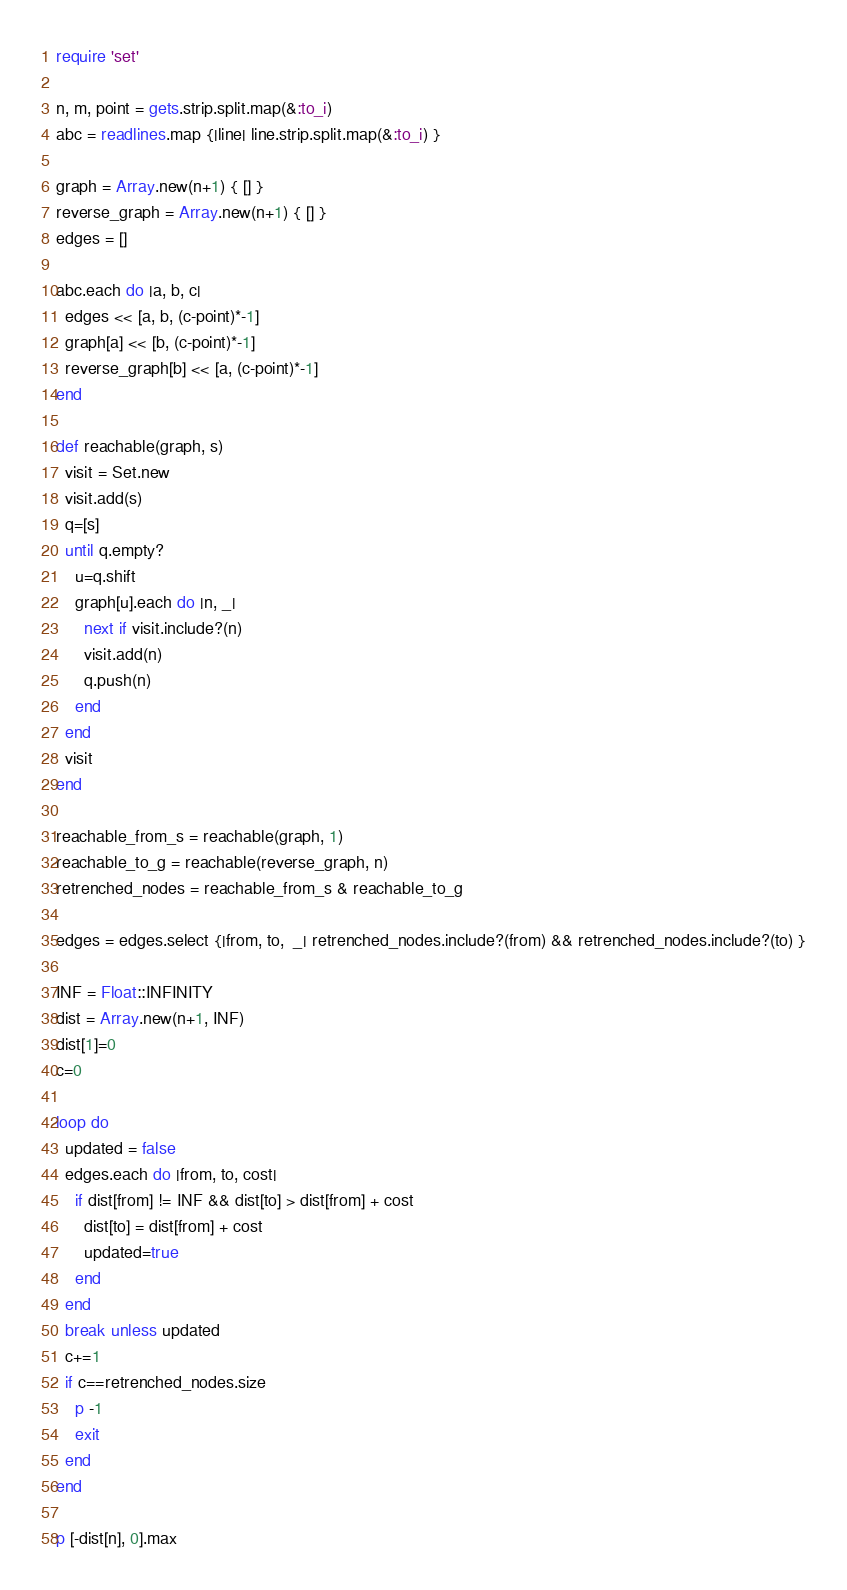Convert code to text. <code><loc_0><loc_0><loc_500><loc_500><_Ruby_>require 'set'

n, m, point = gets.strip.split.map(&:to_i)
abc = readlines.map {|line| line.strip.split.map(&:to_i) }

graph = Array.new(n+1) { [] }
reverse_graph = Array.new(n+1) { [] }
edges = []

abc.each do |a, b, c|
  edges << [a, b, (c-point)*-1]
  graph[a] << [b, (c-point)*-1]
  reverse_graph[b] << [a, (c-point)*-1]
end

def reachable(graph, s)
  visit = Set.new
  visit.add(s)
  q=[s]
  until q.empty?
    u=q.shift
    graph[u].each do |n, _|
      next if visit.include?(n)
      visit.add(n)
      q.push(n)
    end
  end
  visit
end

reachable_from_s = reachable(graph, 1)
reachable_to_g = reachable(reverse_graph, n)
retrenched_nodes = reachable_from_s & reachable_to_g

edges = edges.select {|from, to,  _| retrenched_nodes.include?(from) && retrenched_nodes.include?(to) }

INF = Float::INFINITY
dist = Array.new(n+1, INF)
dist[1]=0
c=0

loop do
  updated = false
  edges.each do |from, to, cost|
    if dist[from] != INF && dist[to] > dist[from] + cost
      dist[to] = dist[from] + cost
      updated=true
    end
  end
  break unless updated
  c+=1
  if c==retrenched_nodes.size
    p -1
    exit
  end
end

p [-dist[n], 0].max
</code> 